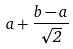Convert formula to latex. <formula><loc_0><loc_0><loc_500><loc_500>a + \frac { b - a } { \sqrt { 2 } }</formula> 